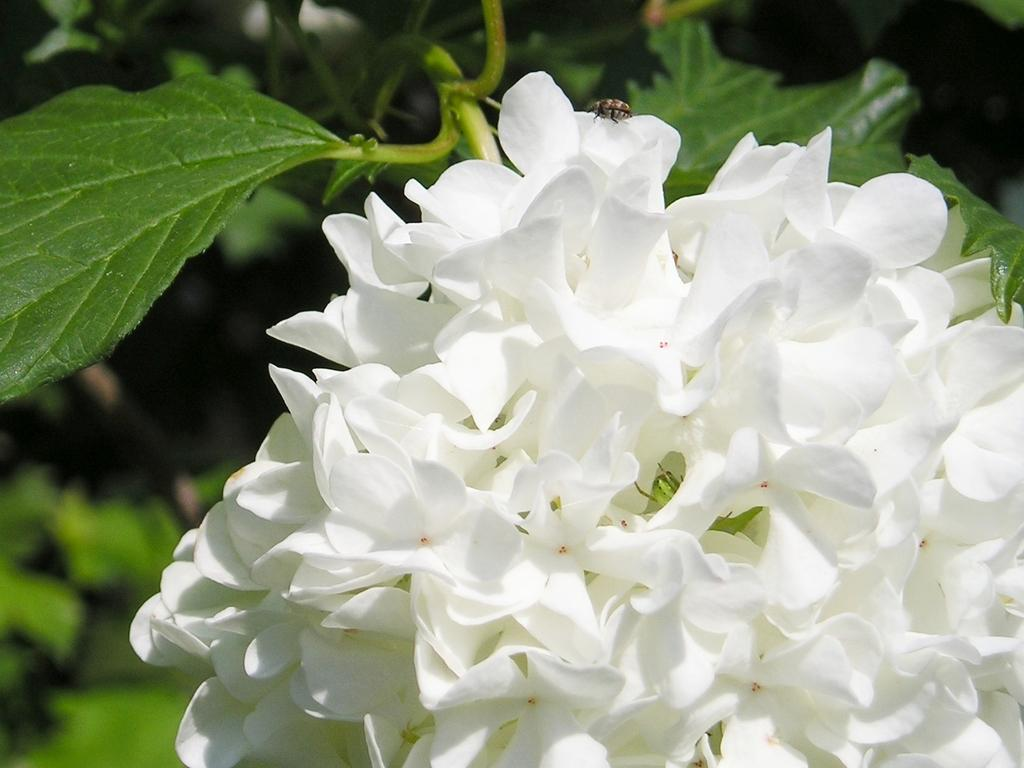What type of plants are present in the image? There are flowers in the image. What color are the flowers? The flowers are white. What else can be seen in the background of the image? There are leaves in the background of the image. Can you describe the insect in the image? There is an insect at the top of the image. What type of magic is being performed by the flowers in the image? There is no magic being performed by the flowers in the image; they are simply white flowers. Is there a battle taking place between the flowers and the insect in the image? There is no battle depicted in the image; the flowers and insect are separate elements. 